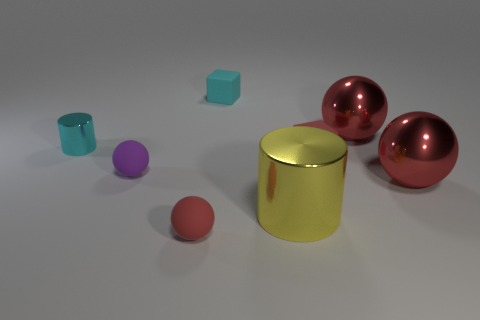What materials are the objects in the image made of? The objects in the image appear to have different materials. The two spheres and the large cylinder have a shiny, reflective surface indicative of a metallic material. The small cylinder and the cube, however, have a matte finish that suggests a non-metallic, possibly plastic, material. 